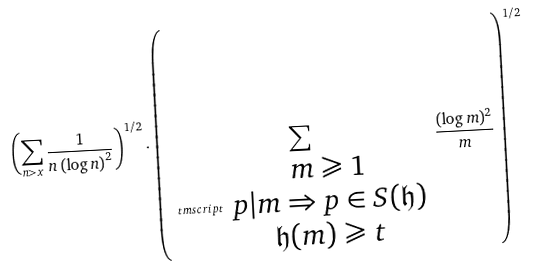<formula> <loc_0><loc_0><loc_500><loc_500>\left ( \sum _ { n > x } \frac { 1 } { n \left ( \log n \right ) ^ { 2 } } \right ) ^ { 1 / 2 } \cdot \left ( \sum _ { \ t m s c r i p t { \begin{array} { c } m \geqslant 1 \\ p | m \Rightarrow p \in S ( \mathfrak { h } ) \\ \mathfrak { h } ( m ) \geqslant t \end{array} } } \frac { ( \log m ) ^ { 2 } } { m } \right ) ^ { 1 / 2 }</formula> 